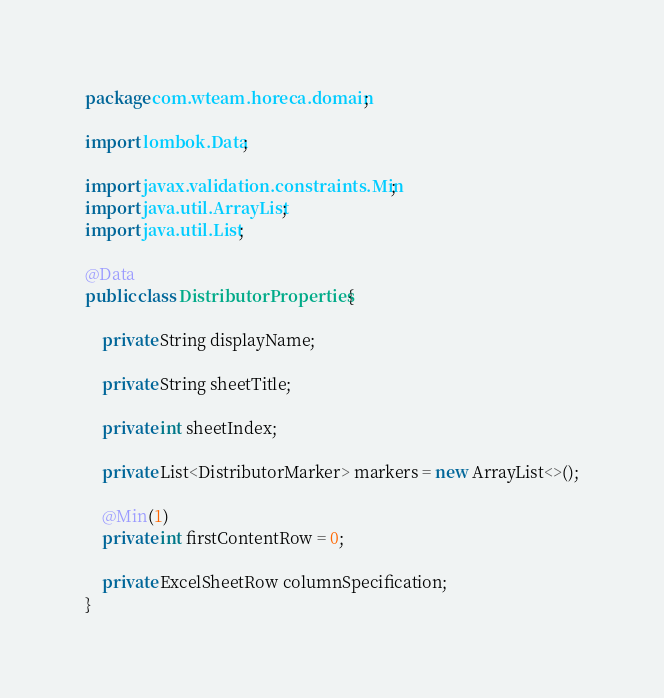Convert code to text. <code><loc_0><loc_0><loc_500><loc_500><_Java_>package com.wteam.horeca.domain;

import lombok.Data;

import javax.validation.constraints.Min;
import java.util.ArrayList;
import java.util.List;

@Data
public class DistributorProperties {

    private String displayName;

    private String sheetTitle;

    private int sheetIndex;

    private List<DistributorMarker> markers = new ArrayList<>();

    @Min(1)
    private int firstContentRow = 0;

    private ExcelSheetRow columnSpecification;
}
</code> 